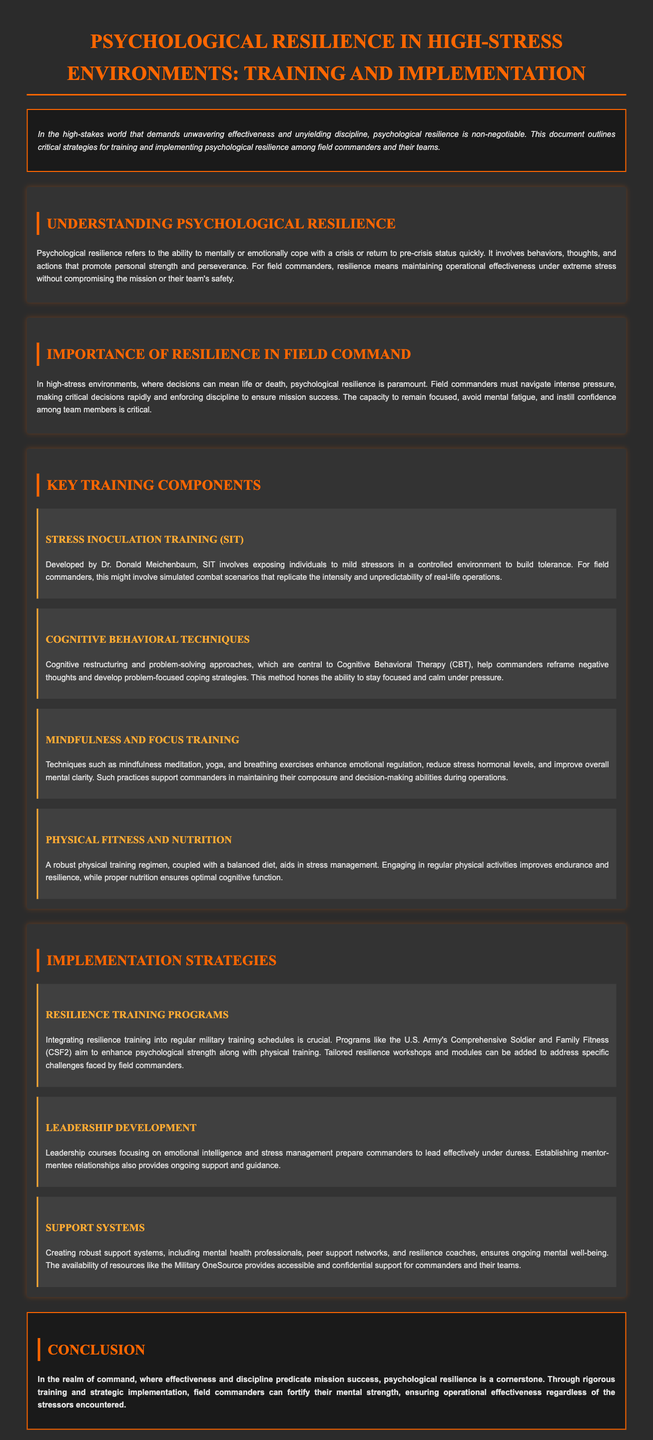What is the main focus of the whitepaper? The whitepaper focuses on strategies for training and implementing psychological resilience in field commanders and their teams under high-stress conditions.
Answer: psychological resilience Who developed Stress Inoculation Training? Stress Inoculation Training was developed by Dr. Donald Meichenbaum.
Answer: Dr. Donald Meichenbaum What is the purpose of Cognitive Behavioral Techniques in the context of the document? Cognitive Behavioral Techniques help commanders reframe negative thoughts and develop problem-focused coping strategies.
Answer: coping strategies How does the document suggest integrating resilience training? The document suggests integrating resilience training into regular military training schedules.
Answer: regular military training schedules What does the abbreviation CSF2 stand for? CSF2 stands for Comprehensive Soldier and Family Fitness.
Answer: Comprehensive Soldier and Family Fitness What is one method mentioned for enhancing emotional regulation? Mindfulness meditation is one method mentioned for enhancing emotional regulation.
Answer: mindfulness meditation Why is physical fitness important according to the whitepaper? Physical fitness improves endurance and resilience, aiding in stress management.
Answer: improve endurance and resilience What is the significance of leadership development in high-stress environments? Leadership development prepares commanders to lead effectively under duress.
Answer: lead effectively under duress What is a key component of support systems mentioned in the document? Robust support systems include mental health professionals.
Answer: mental health professionals 